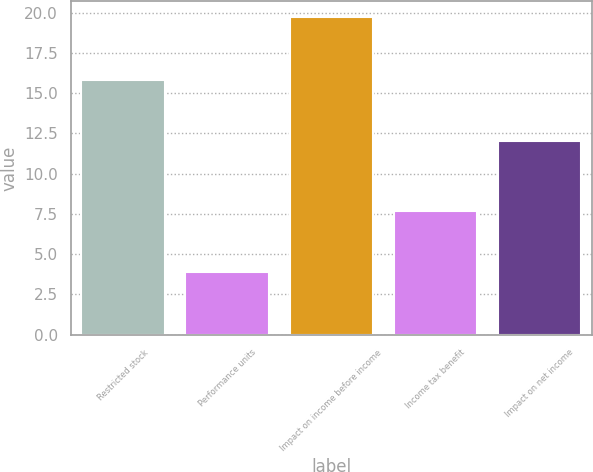Convert chart to OTSL. <chart><loc_0><loc_0><loc_500><loc_500><bar_chart><fcel>Restricted stock<fcel>Performance units<fcel>Impact on income before income<fcel>Income tax benefit<fcel>Impact on net income<nl><fcel>15.8<fcel>3.9<fcel>19.7<fcel>7.7<fcel>12<nl></chart> 